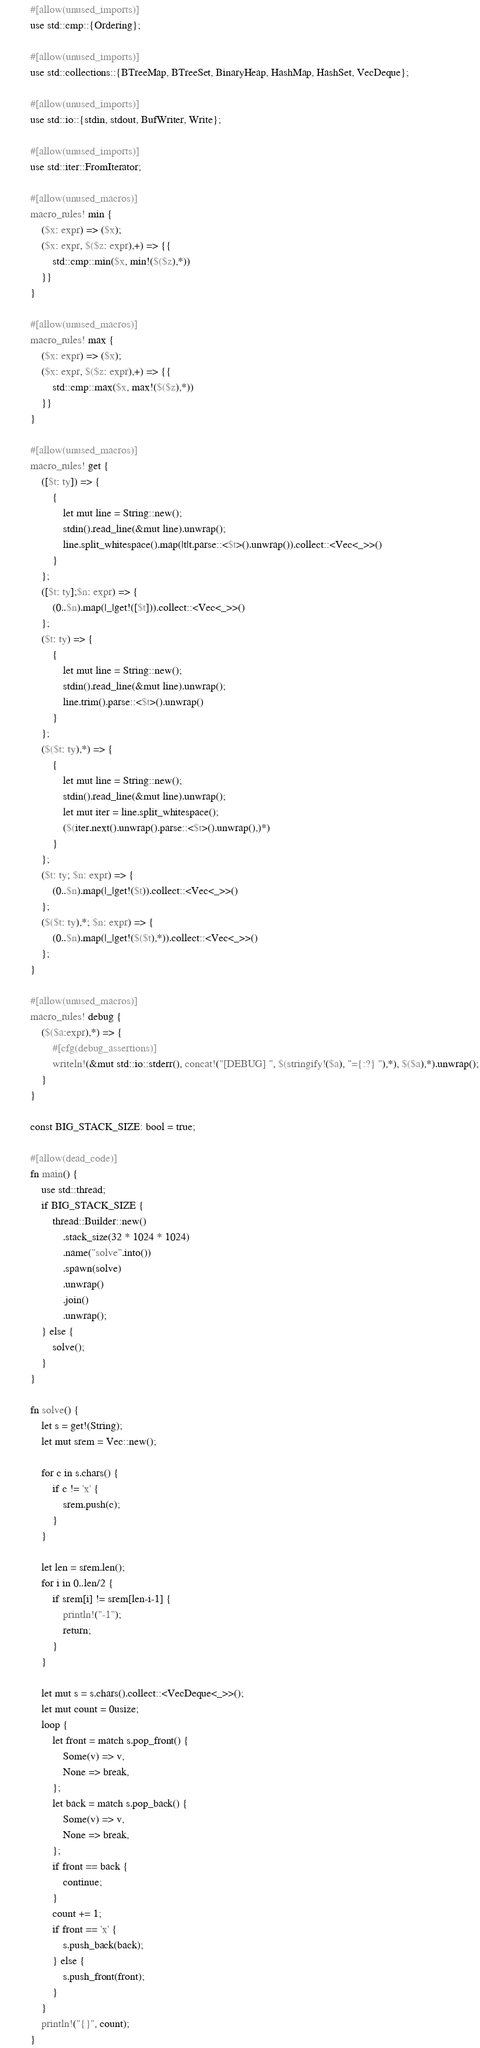<code> <loc_0><loc_0><loc_500><loc_500><_Rust_>#[allow(unused_imports)]
use std::cmp::{Ordering};

#[allow(unused_imports)]
use std::collections::{BTreeMap, BTreeSet, BinaryHeap, HashMap, HashSet, VecDeque};

#[allow(unused_imports)]
use std::io::{stdin, stdout, BufWriter, Write};

#[allow(unused_imports)]
use std::iter::FromIterator;

#[allow(unused_macros)]
macro_rules! min {
    ($x: expr) => ($x);
    ($x: expr, $($z: expr),+) => {{
        std::cmp::min($x, min!($($z),*))
    }}
}

#[allow(unused_macros)]
macro_rules! max {
    ($x: expr) => ($x);
    ($x: expr, $($z: expr),+) => {{
        std::cmp::max($x, max!($($z),*))
    }}
}

#[allow(unused_macros)]
macro_rules! get { 
    ([$t: ty]) => { 
        { 
            let mut line = String::new(); 
            stdin().read_line(&mut line).unwrap(); 
            line.split_whitespace().map(|t|t.parse::<$t>().unwrap()).collect::<Vec<_>>()
        }
    };
    ([$t: ty];$n: expr) => {
        (0..$n).map(|_|get!([$t])).collect::<Vec<_>>()
    };
    ($t: ty) => {
        {
            let mut line = String::new();
            stdin().read_line(&mut line).unwrap();
            line.trim().parse::<$t>().unwrap()
        }
    };
    ($($t: ty),*) => {
        { 
            let mut line = String::new();
            stdin().read_line(&mut line).unwrap();
            let mut iter = line.split_whitespace();
            ($(iter.next().unwrap().parse::<$t>().unwrap(),)*)
        }
    };
    ($t: ty; $n: expr) => {
        (0..$n).map(|_|get!($t)).collect::<Vec<_>>()
    };
    ($($t: ty),*; $n: expr) => {
        (0..$n).map(|_|get!($($t),*)).collect::<Vec<_>>()
    };
}

#[allow(unused_macros)]
macro_rules! debug {
    ($($a:expr),*) => {
        #[cfg(debug_assertions)]
        writeln!(&mut std::io::stderr(), concat!("[DEBUG] ", $(stringify!($a), "={:?} "),*), $($a),*).unwrap();
    }
}

const BIG_STACK_SIZE: bool = true;

#[allow(dead_code)]
fn main() {
    use std::thread;
    if BIG_STACK_SIZE {
        thread::Builder::new()
            .stack_size(32 * 1024 * 1024)
            .name("solve".into())
            .spawn(solve)
            .unwrap()
            .join()
            .unwrap();
    } else {
        solve();
    }
}

fn solve() {
    let s = get!(String);
    let mut srem = Vec::new();
    
    for c in s.chars() {
        if c != 'x' {
            srem.push(c);
        }
    }
    
    let len = srem.len();
    for i in 0..len/2 {
        if srem[i] != srem[len-i-1] {
            println!("-1");
            return;
        }
    }

    let mut s = s.chars().collect::<VecDeque<_>>();
    let mut count = 0usize;
    loop {
        let front = match s.pop_front() {
            Some(v) => v,
            None => break,
        };
        let back = match s.pop_back() {
            Some(v) => v,
            None => break,
        };
        if front == back {
            continue;
        }
        count += 1;
        if front == 'x' {
            s.push_back(back);
        } else {
            s.push_front(front);
        }
    }
    println!("{}", count);
}
</code> 